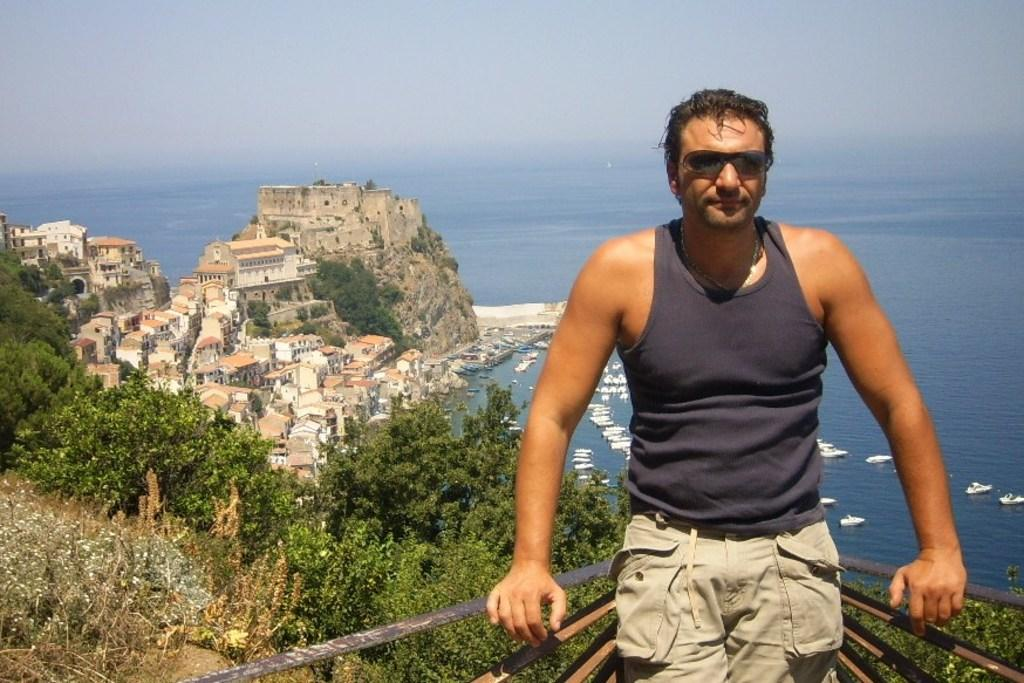What is the main subject of the image? There is a person in the image. What can be seen on the left side of the image? There are trees and buildings on the left side of the image. What is visible in the background of the image? Water and the sky are visible in the background of the image. How many eggs are being used to build the sticks in the image? There are no eggs or sticks present in the image. 